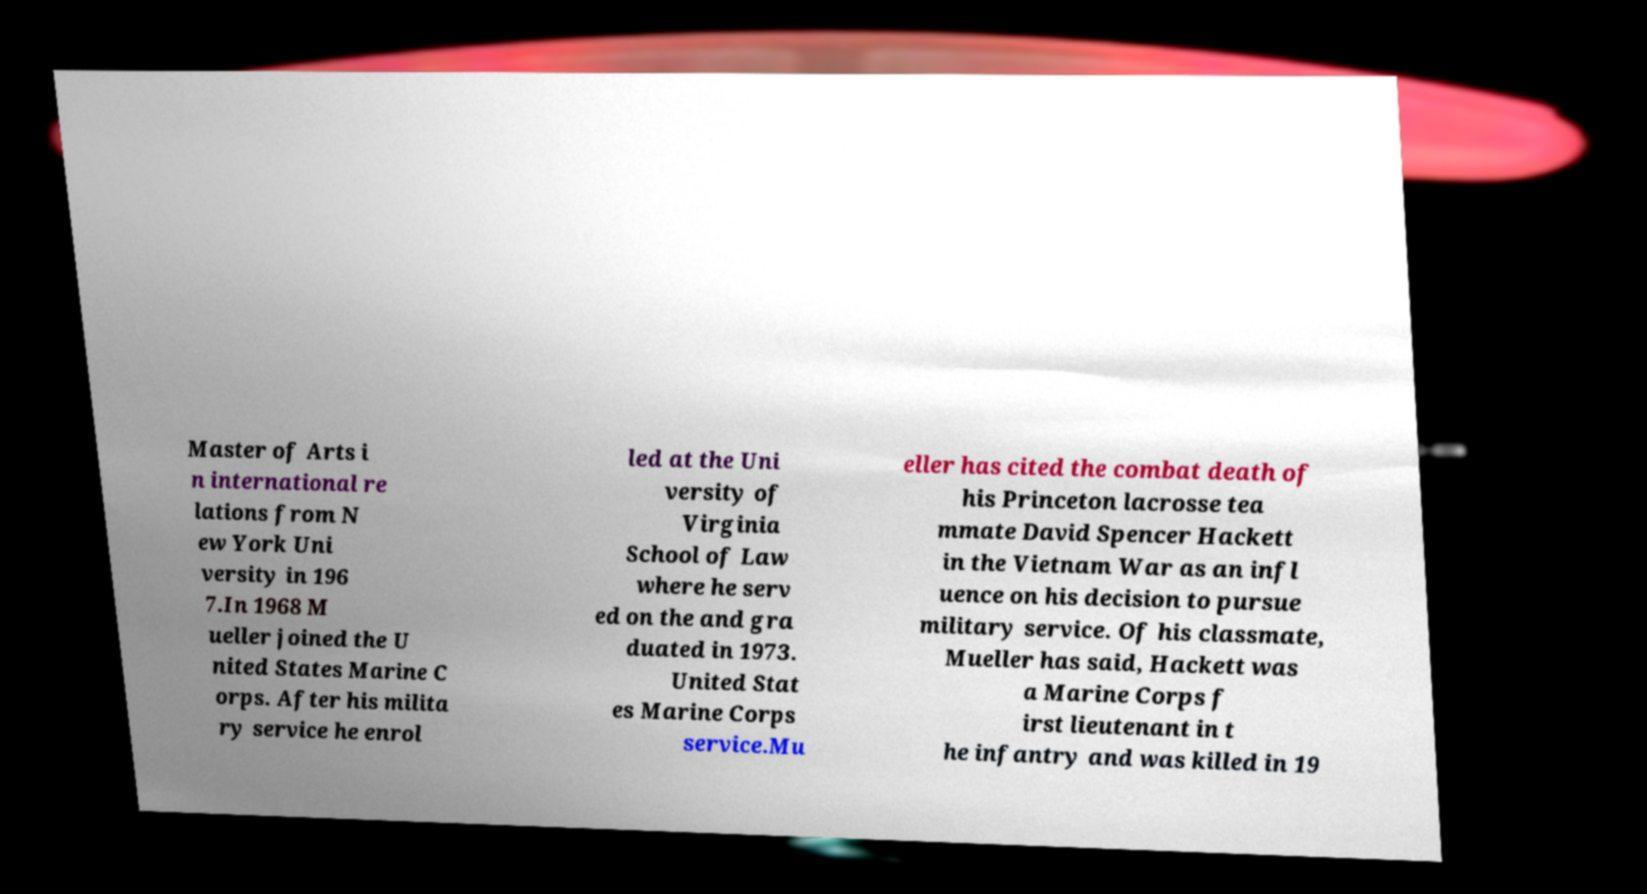For documentation purposes, I need the text within this image transcribed. Could you provide that? Master of Arts i n international re lations from N ew York Uni versity in 196 7.In 1968 M ueller joined the U nited States Marine C orps. After his milita ry service he enrol led at the Uni versity of Virginia School of Law where he serv ed on the and gra duated in 1973. United Stat es Marine Corps service.Mu eller has cited the combat death of his Princeton lacrosse tea mmate David Spencer Hackett in the Vietnam War as an infl uence on his decision to pursue military service. Of his classmate, Mueller has said, Hackett was a Marine Corps f irst lieutenant in t he infantry and was killed in 19 